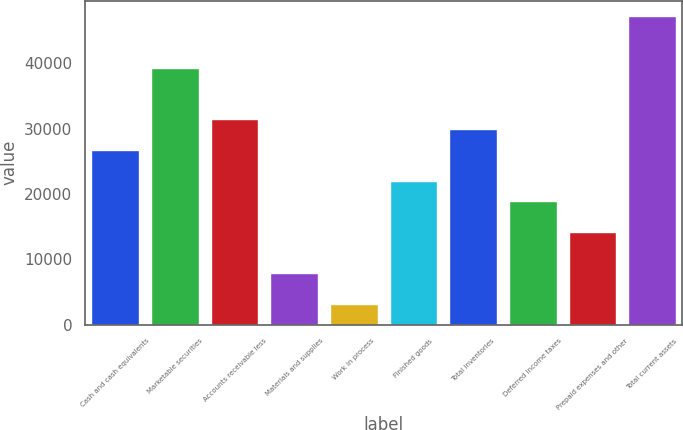Convert chart to OTSL. <chart><loc_0><loc_0><loc_500><loc_500><bar_chart><fcel>Cash and cash equivalents<fcel>Marketable securities<fcel>Accounts receivable less<fcel>Materials and supplies<fcel>Work in process<fcel>Finished goods<fcel>Total inventories<fcel>Deferred income taxes<fcel>Prepaid expenses and other<fcel>Total current assets<nl><fcel>26745.6<fcel>39320<fcel>31461<fcel>7884<fcel>3168.6<fcel>22030.2<fcel>29889.2<fcel>18886.6<fcel>14171.2<fcel>47179<nl></chart> 